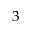<formula> <loc_0><loc_0><loc_500><loc_500>3</formula> 